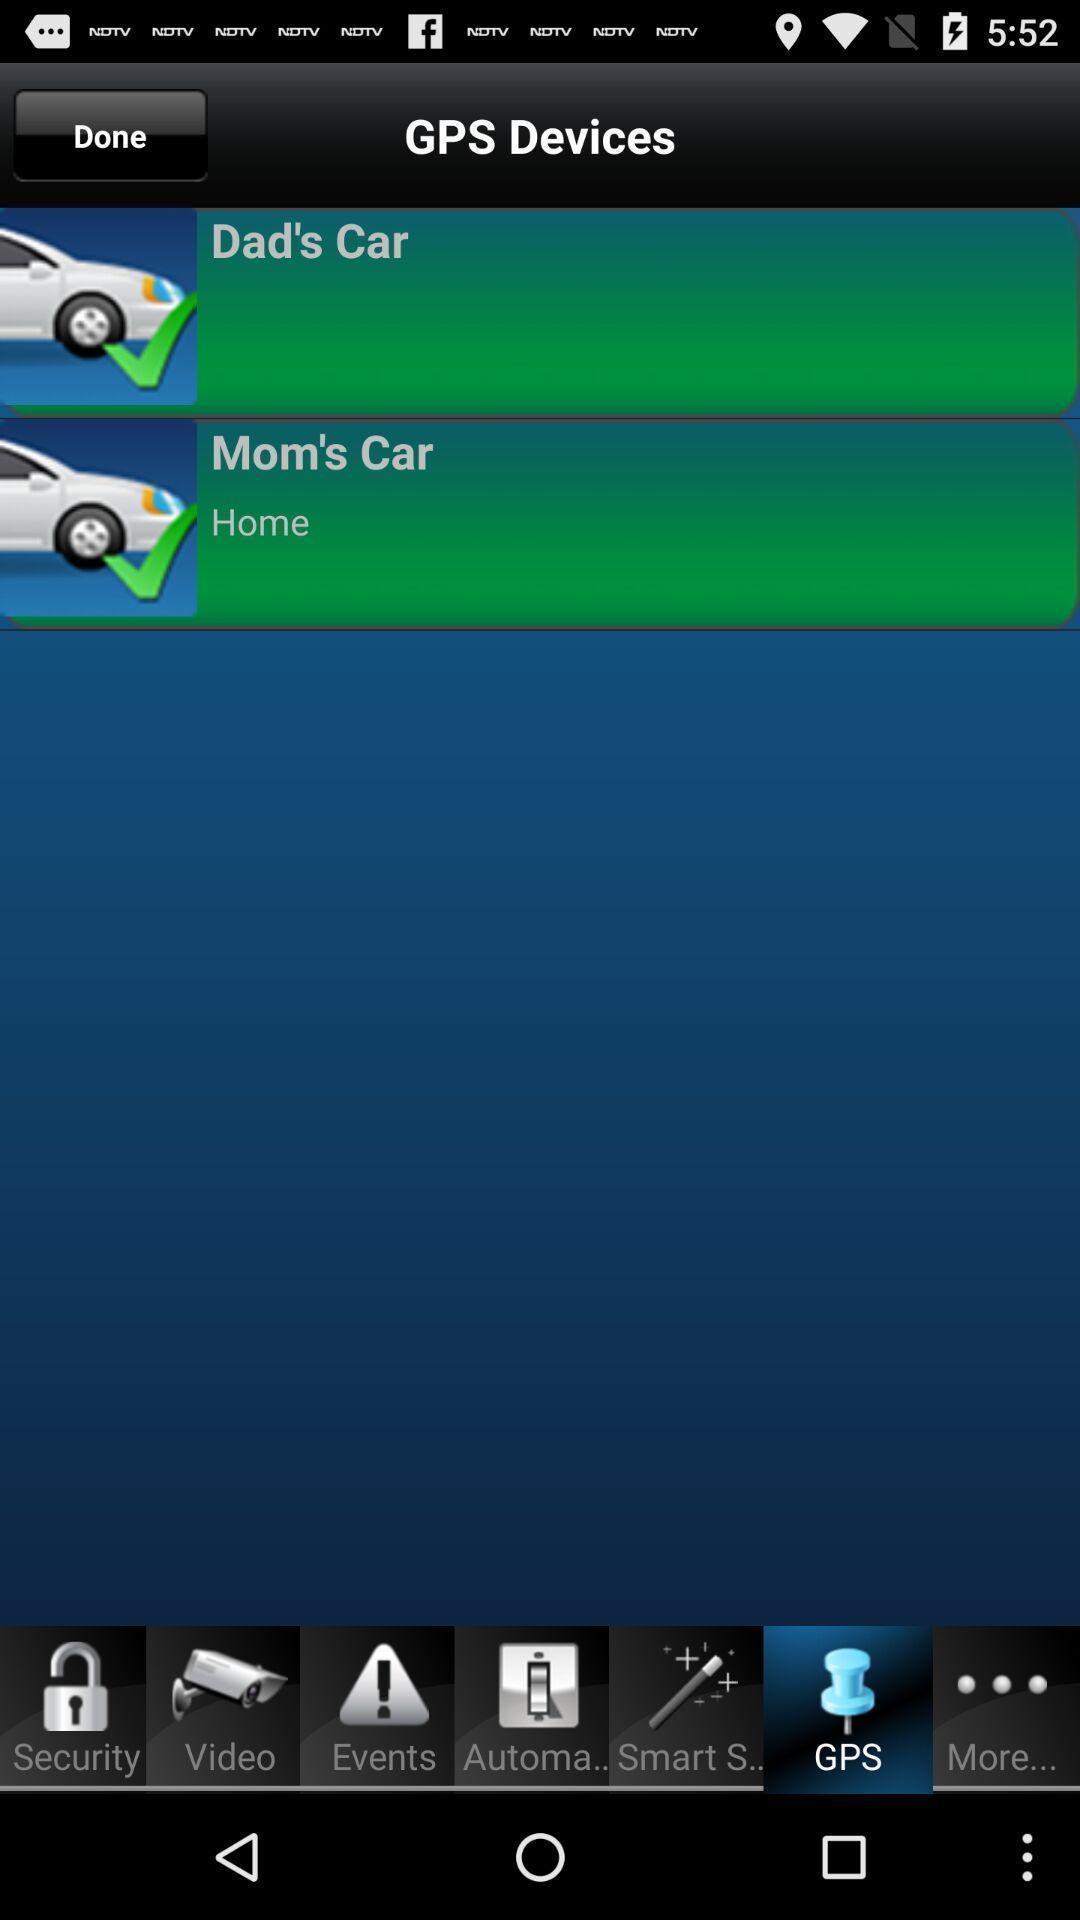Provide a detailed account of this screenshot. Page showing the options in gps app. 